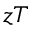<formula> <loc_0><loc_0><loc_500><loc_500>z T</formula> 